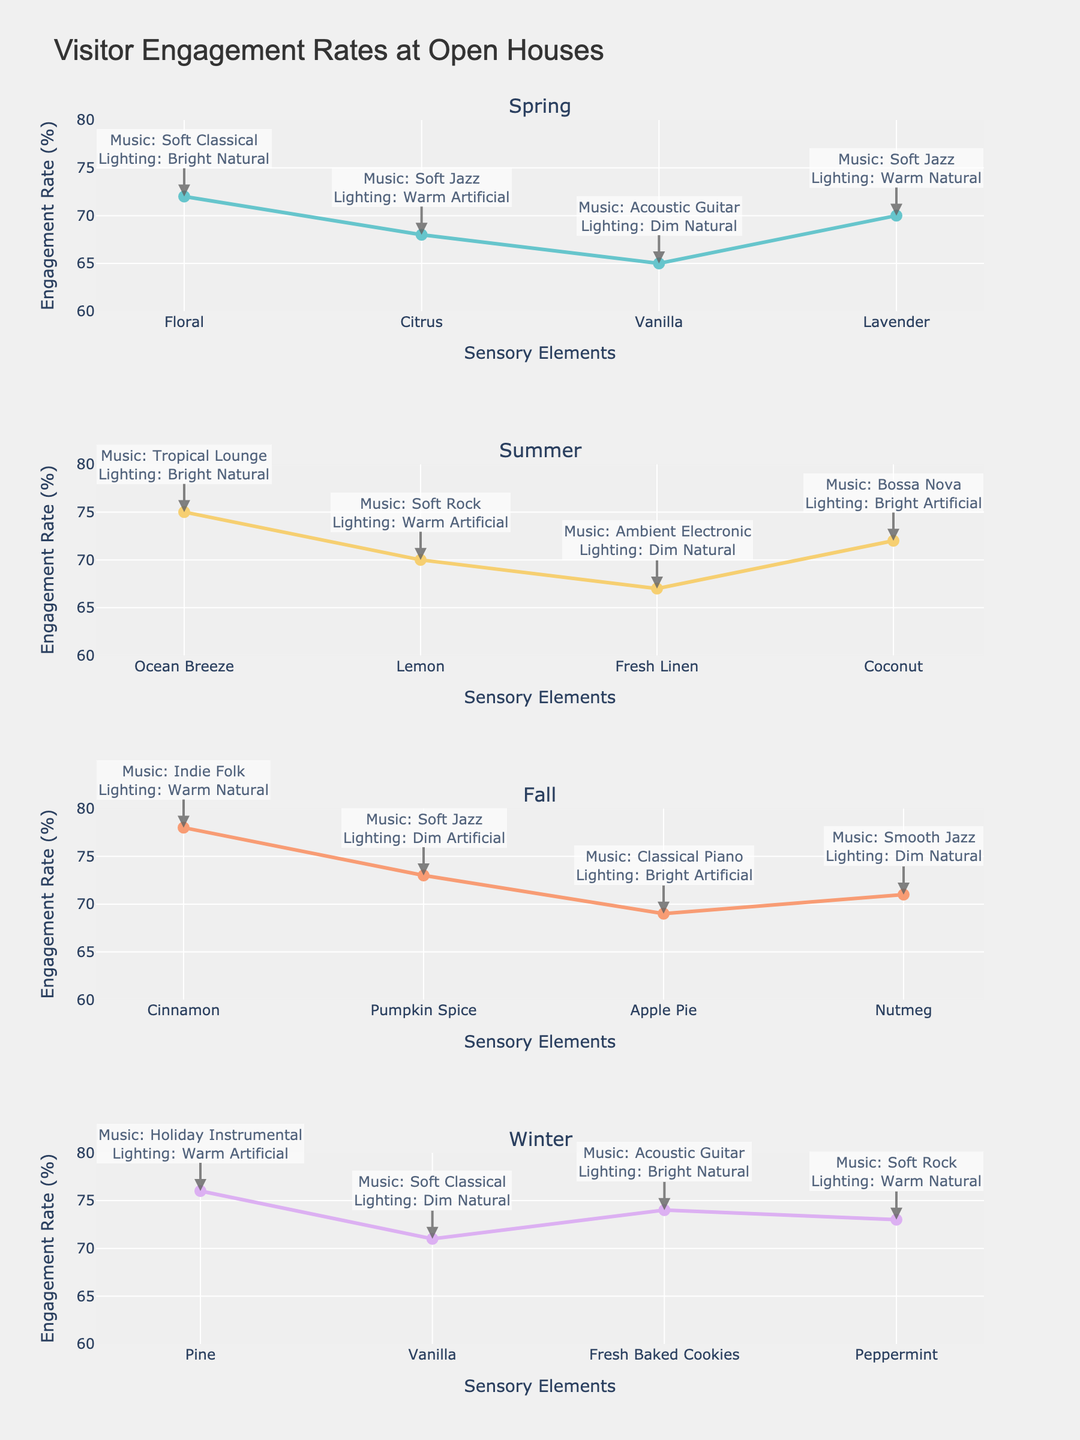What is the highest visitor engagement rate observed in spring? Look at the Spring plot and identify the highest Y-axis value among the engagement rates. The maximum value is 72 for the scent 'Floral'.
Answer: 72 Which season has the highest overall engagement rate? Compare the highest engagement rate value across all four seasonal plots. Fall has the highest engagement rate of 78 with the scent 'Cinnamon'.
Answer: Fall What is the difference between the lowest engagement rate in fall and the highest engagement rate in spring? The lowest engagement rate in fall is 69 (Apple Pie), and the highest in spring is 72 (Floral). Compute the difference: 72 - 69 = 3.
Answer: 3 Which sensory element combination results in an engagement rate of 75 in summer? Look at the Summer plot and find the sensory element combination that corresponds to the engagement rate of 75. It is 'Ocean Breeze' scent, 'Tropical Lounge' music, with 'Bright Natural' lighting.
Answer: Ocean Breeze, Tropical Lounge, Bright Natural Did any season achieve an engagement rate of exactly 70? Review each seasonal plot for engagement rates of 70. In Spring, 'Lavender' with 'Soft Jazz' and 'Warm Natural' lighting achieved exactly 70.
Answer: Yes, Spring Among the scents 'Vanilla' in Spring and Winter, which had a higher engagement rate? Compare the engagement rate of 'Vanilla' in Spring (65) and Winter (71). Winter has a higher engagement rate.
Answer: Winter What is the average engagement rate in the Winter season? Calculate the average of the engagement rates in Winter (76, 71, 74, 73). The sum is 294 and the average is 294 / 4 = 73.5.
Answer: 73.5 Which music genre resulted in the highest engagement rate in the Fall season? Review the Fall plot for the highest engagement rate (78) and note the corresponding music genre, which is 'Indie Folk'.
Answer: Indie Folk How does the engagement rate for 'Soft Jazz' music compare between Spring and Fall? Identify the engagement rates for 'Soft Jazz' in both seasons: Spring (68 for Citrus, 70 for Lavender) and Fall (73 for Pumpkin Spice). The highest engagement rate for 'Soft Jazz' is 73 (Fall).
Answer: Higher in Fall Which scent had the lowest engagement rate in Summer? Review the Summer plot and identify the lowest engagement rate, which is 67 for 'Fresh Linen'.
Answer: Fresh Linen 